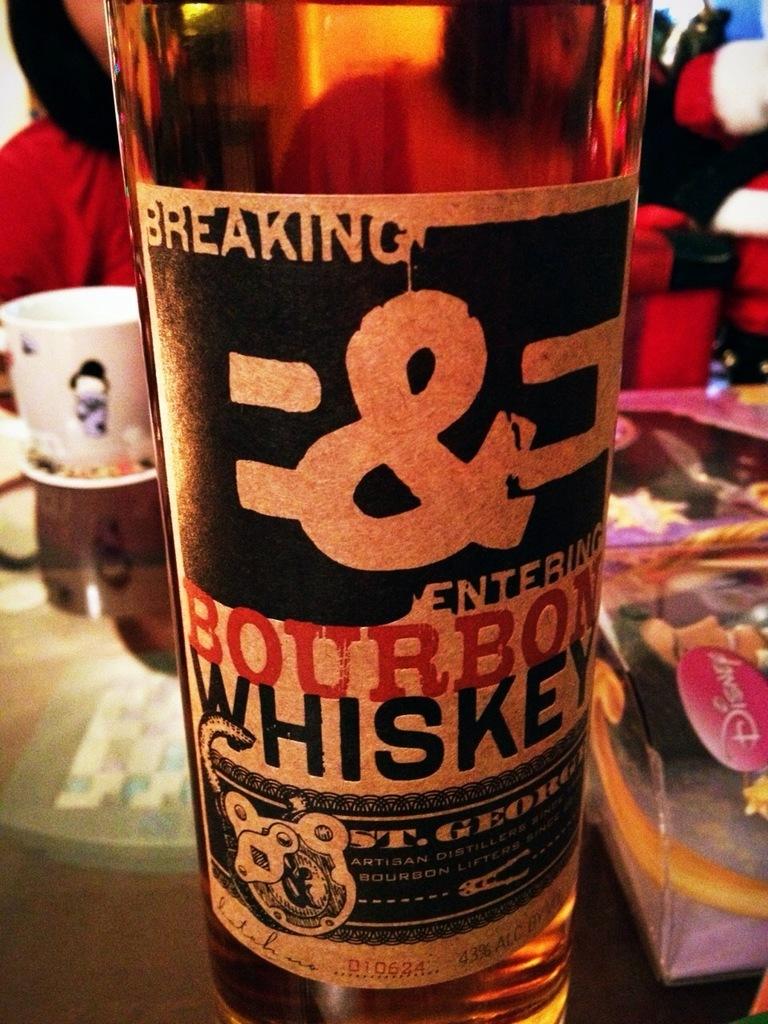What kind of liquor is this?
Your answer should be very brief. Bourbon whiskey. Name this bourbon?
Your answer should be compact. Breaking & entering. 